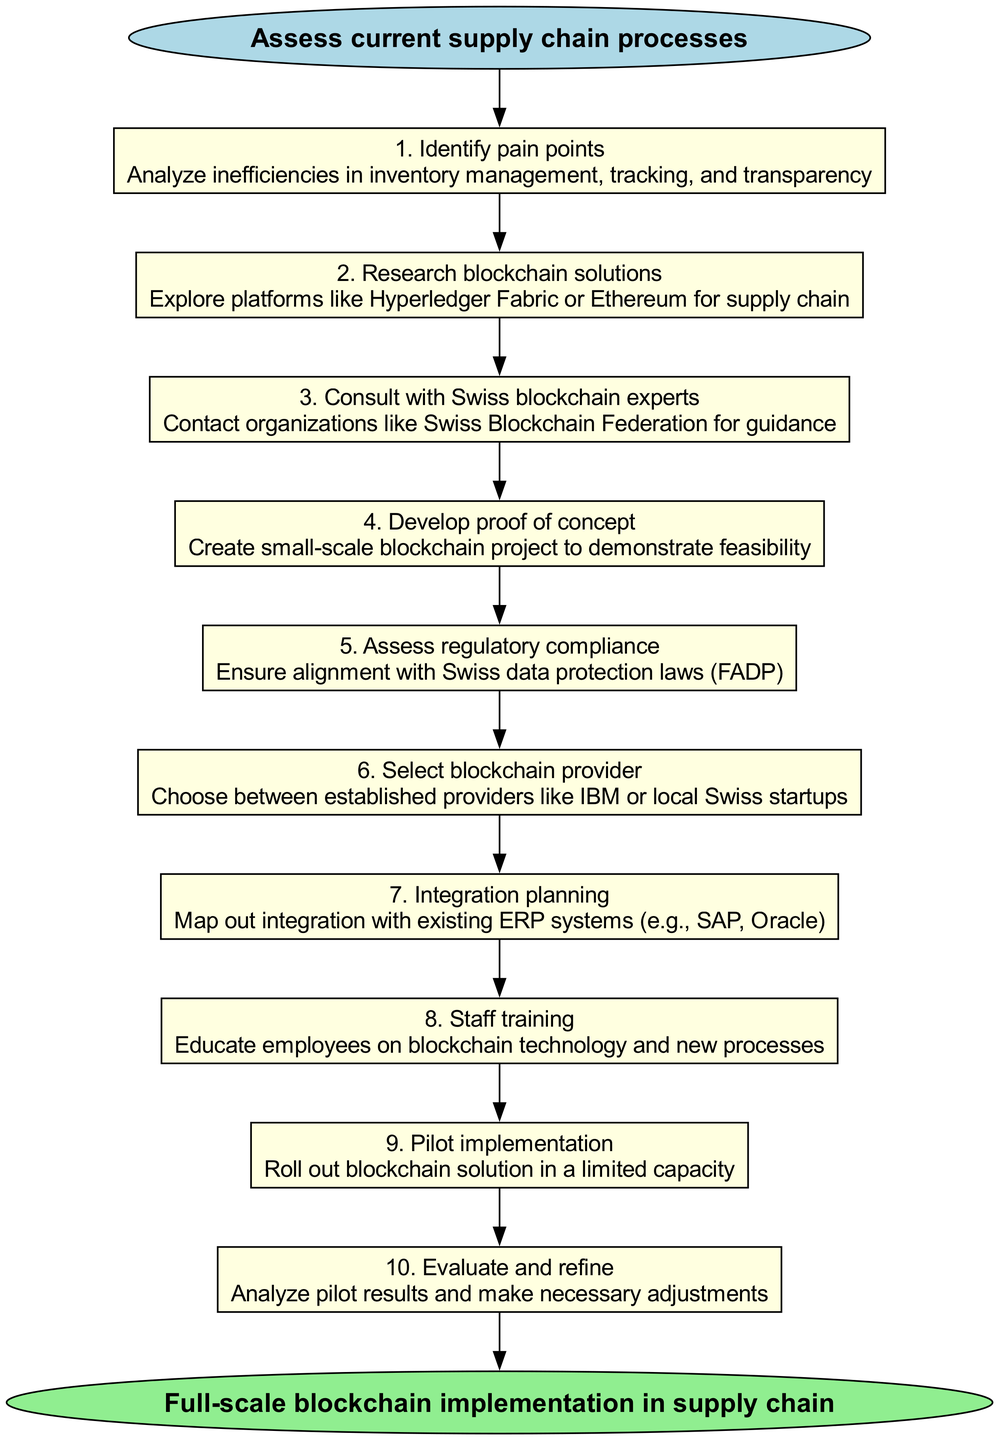What is the starting point of the clinical pathway? The diagram lists "Assess current supply chain processes" as the first step, which serves as the starting point of the clinical pathway.
Answer: Assess current supply chain processes How many steps are involved in this clinical pathway? The diagram outlines 10 steps, each representing a key process in adopting blockchain technology for supply chain management.
Answer: 10 Which step directly follows "Identify pain points"? According to the diagram, "Research blockchain solutions" is the step that comes immediately after "Identify pain points."
Answer: Research blockchain solutions What is the endpoint of the clinical pathway? The final node in the diagram states that the endpoint is "Full-scale blockchain implementation in supply chain."
Answer: Full-scale blockchain implementation in supply chain Which step requires consultation with Swiss blockchain experts? The step titled "Consult with Swiss blockchain experts" specifically mentions the consultation process with organizations like the Swiss Blockchain Federation.
Answer: Consult with Swiss blockchain experts What is the purpose of developing a proof of concept? The diagram indicates that developing a proof of concept is intended to create a small-scale blockchain project to demonstrate feasibility, which helps validate the concept before full implementation.
Answer: Create small-scale blockchain project to demonstrate feasibility Which steps are involved in the evaluation process of the pilot implementation? The pathway includes "Pilot implementation" followed by "Evaluate and refine," indicating that evaluating the pilot implementation is a critical step after pilot execution.
Answer: Evaluate and refine What are the last two steps in the clinical pathway? The last two steps are "Pilot implementation" and "Evaluate and refine," which precede the final endpoint of the clinical pathway.
Answer: Pilot implementation, Evaluate and refine Which step comes before selecting a blockchain provider? According to the diagram, "Assess regulatory compliance" is the step that occurs just prior to selecting a blockchain provider.
Answer: Assess regulatory compliance 